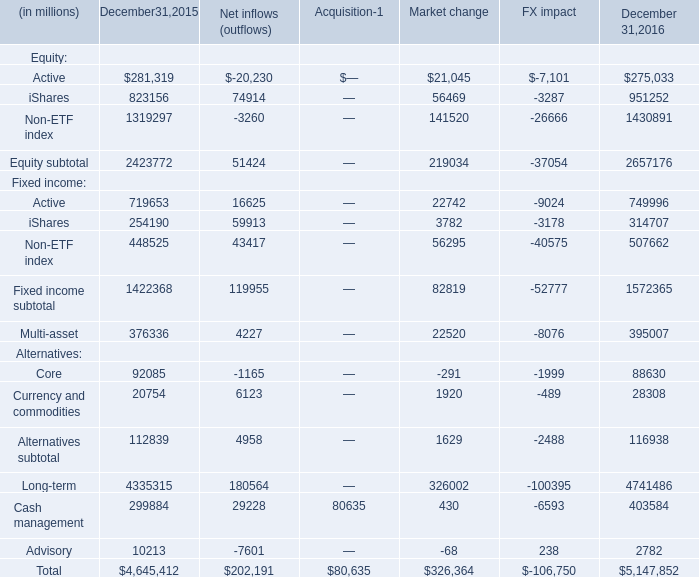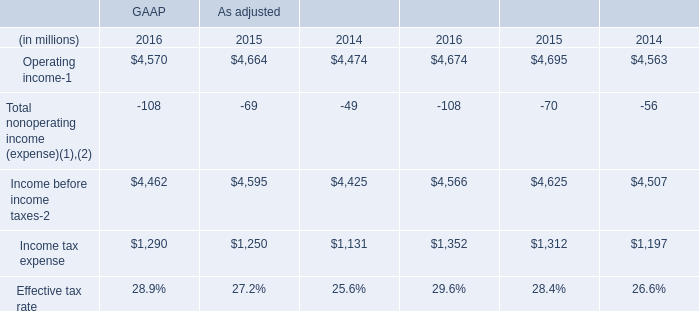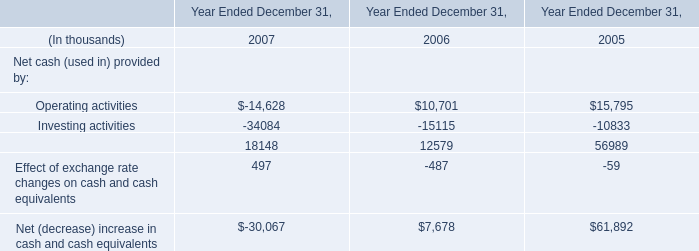What's the total amount of the iShares in the years where Total is greater than 5000000? (in million) 
Answer: 951252. 